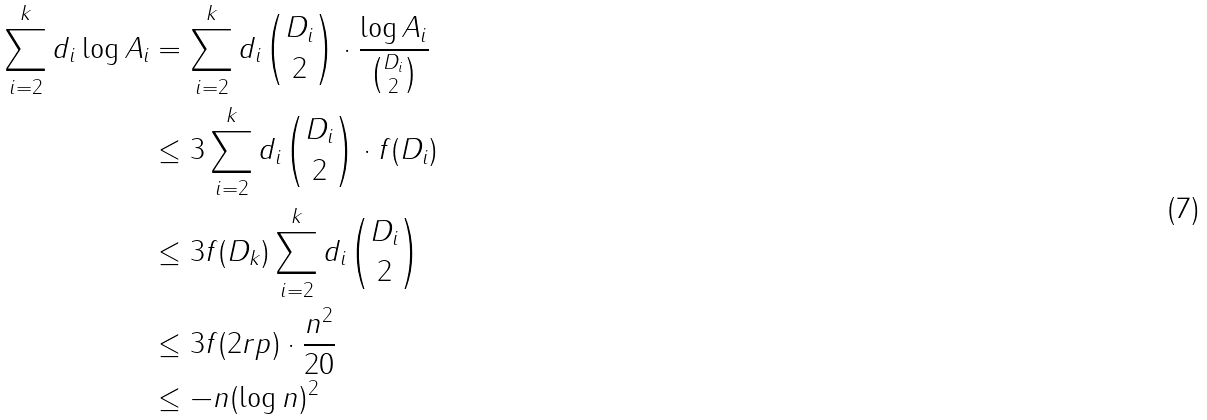Convert formula to latex. <formula><loc_0><loc_0><loc_500><loc_500>\sum _ { i = 2 } ^ { k } d _ { i } \log A _ { i } & = \sum _ { i = 2 } ^ { k } d _ { i } \binom { D _ { i } } { 2 } \cdot \frac { \log A _ { i } } { \binom { D _ { i } } { 2 } } \\ & \leq 3 \sum _ { i = 2 } ^ { k } d _ { i } \binom { D _ { i } } { 2 } \cdot f ( D _ { i } ) \\ & \leq 3 f ( D _ { k } ) \sum _ { i = 2 } ^ { k } d _ { i } \binom { D _ { i } } { 2 } \\ & \leq 3 f ( 2 r p ) \cdot \frac { n ^ { 2 } } { 2 0 } \\ & \leq - n ( \log n ) ^ { 2 }</formula> 